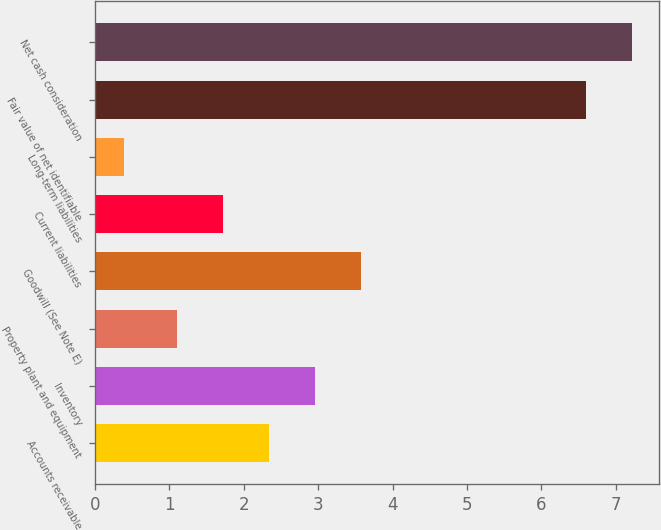Convert chart to OTSL. <chart><loc_0><loc_0><loc_500><loc_500><bar_chart><fcel>Accounts receivable<fcel>Inventory<fcel>Property plant and equipment<fcel>Goodwill (See Note E)<fcel>Current liabilities<fcel>Long-term liabilities<fcel>Fair value of net identifiable<fcel>Net cash consideration<nl><fcel>2.34<fcel>2.96<fcel>1.1<fcel>3.58<fcel>1.72<fcel>0.4<fcel>6.6<fcel>7.22<nl></chart> 